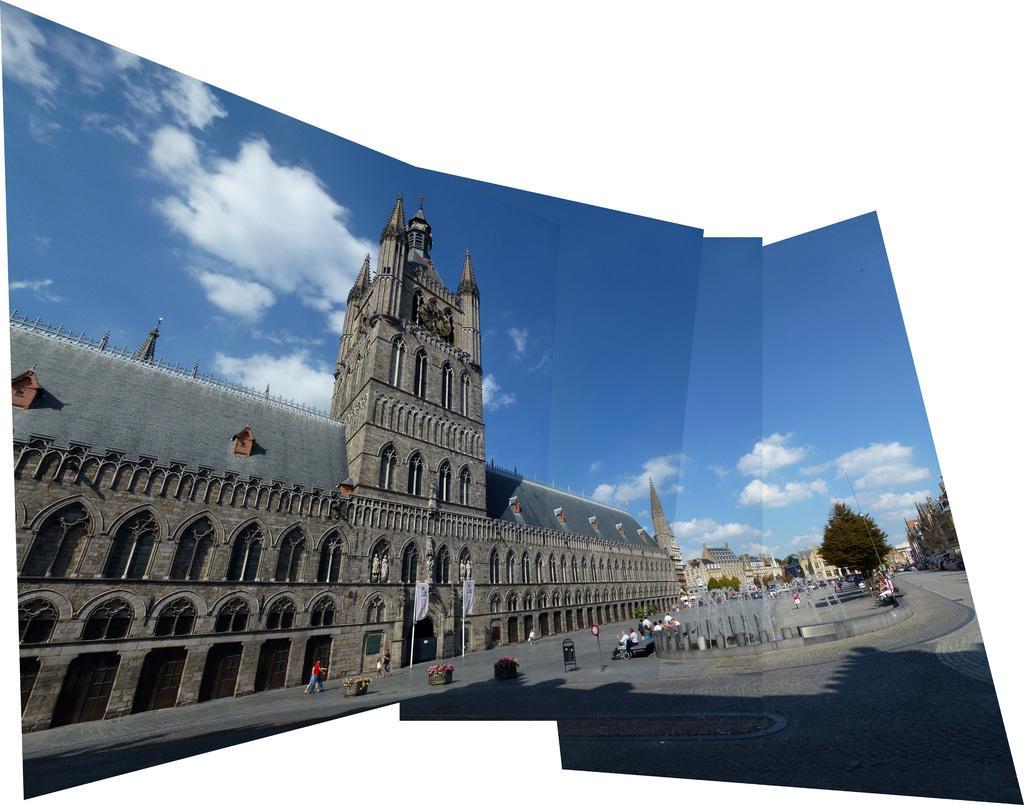Describe this image in one or two sentences. In this image in the middle, there is a steeple, window, some people, fountain, water, trees, buildings, sky and clouds. 